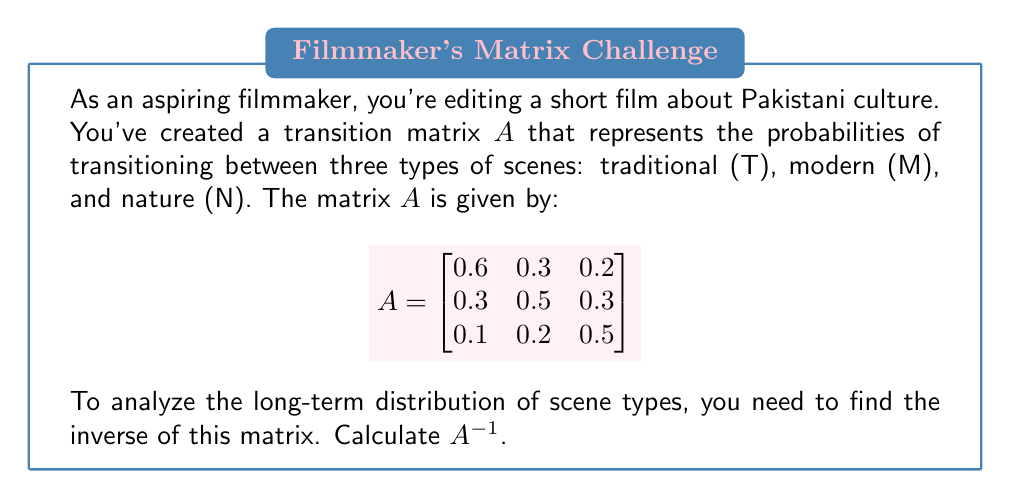Give your solution to this math problem. To find the inverse of matrix $A$, we'll follow these steps:

1) First, we need to calculate the determinant of $A$:
   $\det(A) = 0.6(0.5 \times 0.5 - 0.3 \times 0.2) - 0.3(0.3 \times 0.5 - 0.1 \times 0.2) + 0.2(0.3 \times 0.2 - 0.1 \times 0.5)$
   $= 0.6(0.25 - 0.06) - 0.3(0.15 - 0.02) + 0.2(0.06 - 0.05)$
   $= 0.6(0.19) - 0.3(0.13) + 0.2(0.01)$
   $= 0.114 - 0.039 + 0.002 = 0.077$

2) Now, we calculate the adjugate matrix. First, we find the cofactor matrix:
   $C_{11} = 0.5 \times 0.5 - 0.3 \times 0.2 = 0.19$
   $C_{12} = -(0.3 \times 0.5 - 0.1 \times 0.2) = -0.13$
   $C_{13} = 0.3 \times 0.2 - 0.1 \times 0.5 = 0.01$
   $C_{21} = -(0.5 \times 0.2 - 0.3 \times 0.2) = -0.04$
   $C_{22} = 0.6 \times 0.5 - 0.2 \times 0.1 = 0.28$
   $C_{23} = -(0.6 \times 0.2 - 0.2 \times 0.3) = -0.06$
   $C_{31} = 0.5 \times 0.3 - 0.3 \times 0.3 = 0.06$
   $C_{32} = -(0.6 \times 0.3 - 0.3 \times 0.2) = -0.12$
   $C_{33} = 0.6 \times 0.5 - 0.3 \times 0.3 = 0.21$

3) The adjugate matrix is the transpose of the cofactor matrix:
   $$\text{adj}(A) = \begin{bmatrix}
   0.19 & -0.04 & 0.06 \\
   -0.13 & 0.28 & -0.12 \\
   0.01 & -0.06 & 0.21
   \end{bmatrix}$$

4) Finally, we calculate $A^{-1} = \frac{1}{\det(A)} \times \text{adj}(A)$:
   $$A^{-1} = \frac{1}{0.077} \times \begin{bmatrix}
   0.19 & -0.04 & 0.06 \\
   -0.13 & 0.28 & -0.12 \\
   0.01 & -0.06 & 0.21
   \end{bmatrix}$$

5) Simplifying:
   $$A^{-1} = \begin{bmatrix}
   2.47 & -0.52 & 0.78 \\
   -1.69 & 3.64 & -1.56 \\
   0.13 & -0.78 & 2.73
   \end{bmatrix}$$
Answer: $$A^{-1} = \begin{bmatrix}
2.47 & -0.52 & 0.78 \\
-1.69 & 3.64 & -1.56 \\
0.13 & -0.78 & 2.73
\end{bmatrix}$$ 